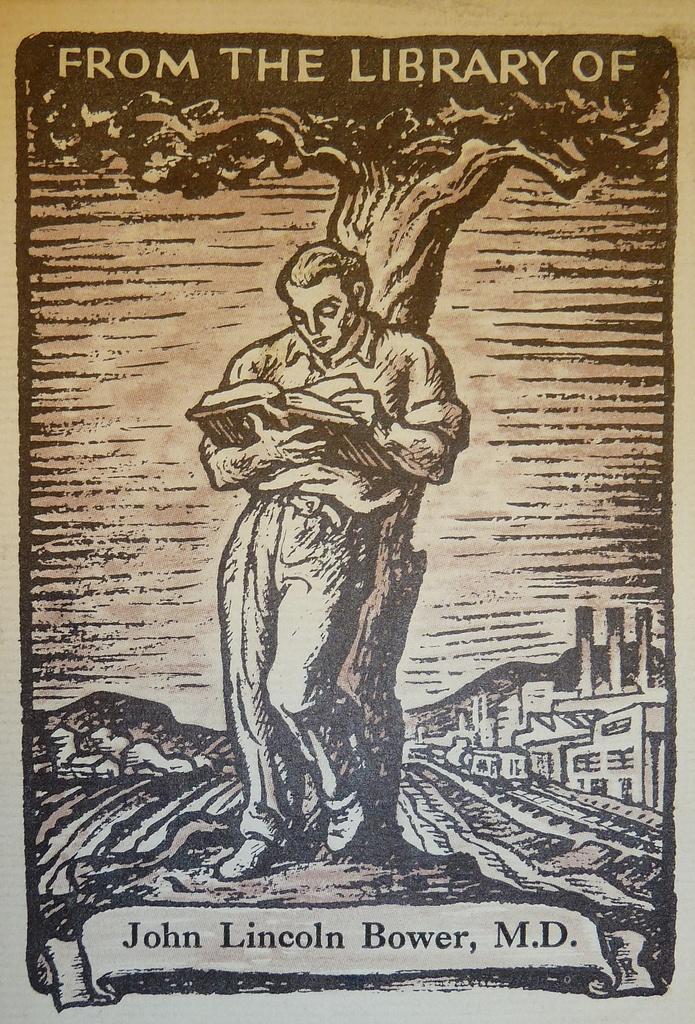Could you give a brief overview of what you see in this image? In this image we can see a poster, here a man is standing and holding a book in the hand, here is the tree. 